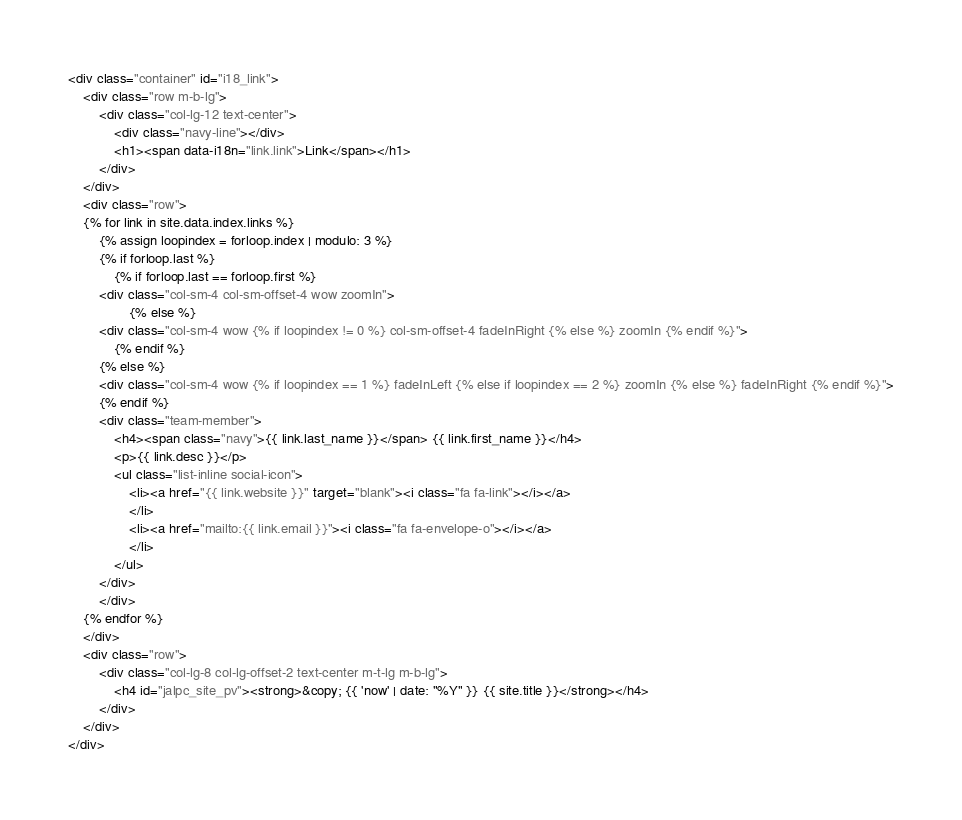<code> <loc_0><loc_0><loc_500><loc_500><_HTML_><div class="container" id="i18_link">
    <div class="row m-b-lg">
        <div class="col-lg-12 text-center">
            <div class="navy-line"></div>
            <h1><span data-i18n="link.link">Link</span></h1>
        </div>
    </div>
    <div class="row">
    {% for link in site.data.index.links %}
        {% assign loopindex = forloop.index | modulo: 3 %}
        {% if forloop.last %}
            {% if forloop.last == forloop.first %}
        <div class="col-sm-4 col-sm-offset-4 wow zoomIn">
                {% else %}
        <div class="col-sm-4 wow {% if loopindex != 0 %} col-sm-offset-4 fadeInRight {% else %} zoomIn {% endif %}">
            {% endif %}
        {% else %}
        <div class="col-sm-4 wow {% if loopindex == 1 %} fadeInLeft {% else if loopindex == 2 %} zoomIn {% else %} fadeInRight {% endif %}">
        {% endif %}
        <div class="team-member">
            <h4><span class="navy">{{ link.last_name }}</span> {{ link.first_name }}</h4>
            <p>{{ link.desc }}</p>
            <ul class="list-inline social-icon">
                <li><a href="{{ link.website }}" target="blank"><i class="fa fa-link"></i></a>
                </li>
                <li><a href="mailto:{{ link.email }}"><i class="fa fa-envelope-o"></i></a>
                </li>
            </ul>
        </div>
        </div>
    {% endfor %}
    </div>
    <div class="row">
        <div class="col-lg-8 col-lg-offset-2 text-center m-t-lg m-b-lg">
            <h4 id="jalpc_site_pv"><strong>&copy; {{ 'now' | date: "%Y" }} {{ site.title }}</strong></h4>
        </div>
    </div>
</div>
</code> 